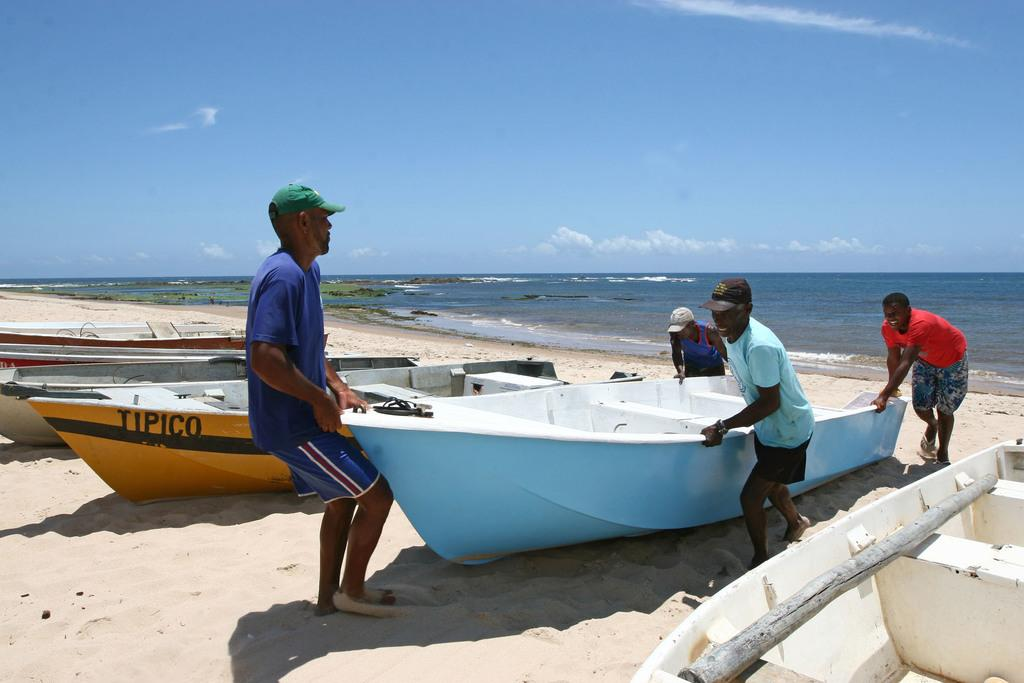How many people are in the image? There are four men in the image. What are the men doing in the image? The men are trying to pull a boat in the image. Are there any boats visible in the image? Yes, there are boats in the image. What can be seen on the right side of the image? The right side of the image features the sea. What is visible at the top of the image? The sky is visible at the top of the image. What type of wren can be seen flying in the image? There is no wren present in the image; it features four men pulling a boat and the sea. What is the profit margin of the boat in the image? There is no information about the profit margin of the boat in the image, as it is focused on the men pulling the boat. 